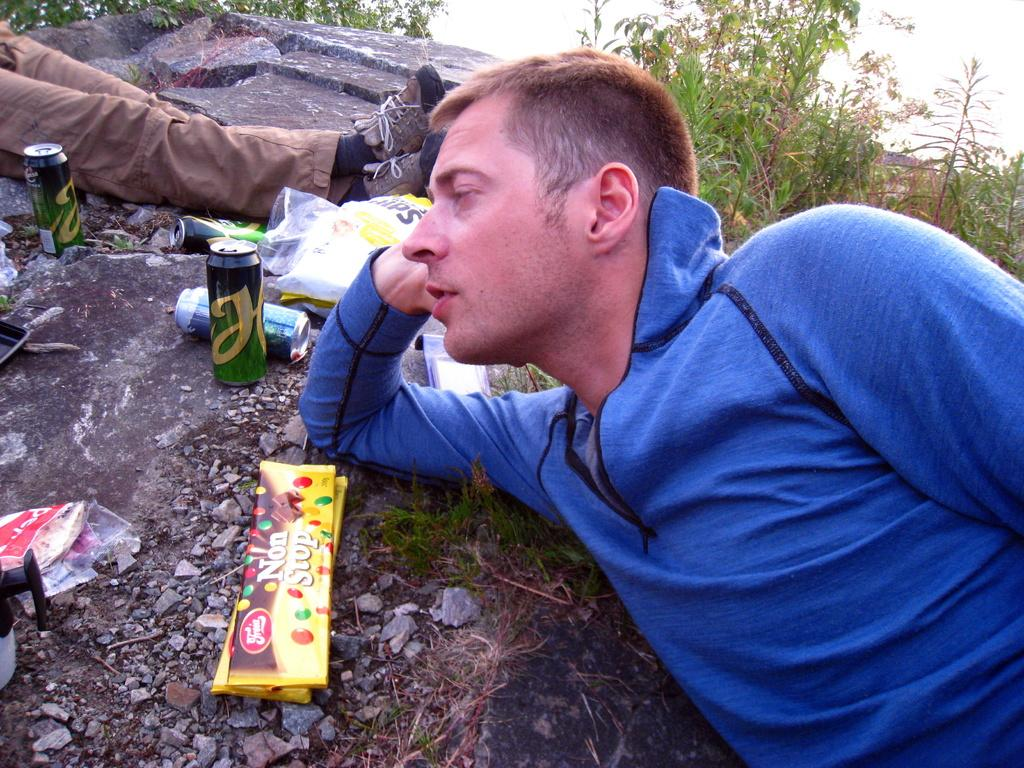What is the position of the person in the image? There is a person lying on the ground in the image. Which part of the person's body is visible? The person's legs are visible in the image. What type of objects can be seen in the image besides the person? There are tins, stones, and plants in the image. Can you describe the other unspecified objects in the image? Unfortunately, the facts provided do not specify the nature of the other unspecified objects in the image. What type of suit is the person wearing in the image? There is no mention of a suit in the image or the provided facts. 